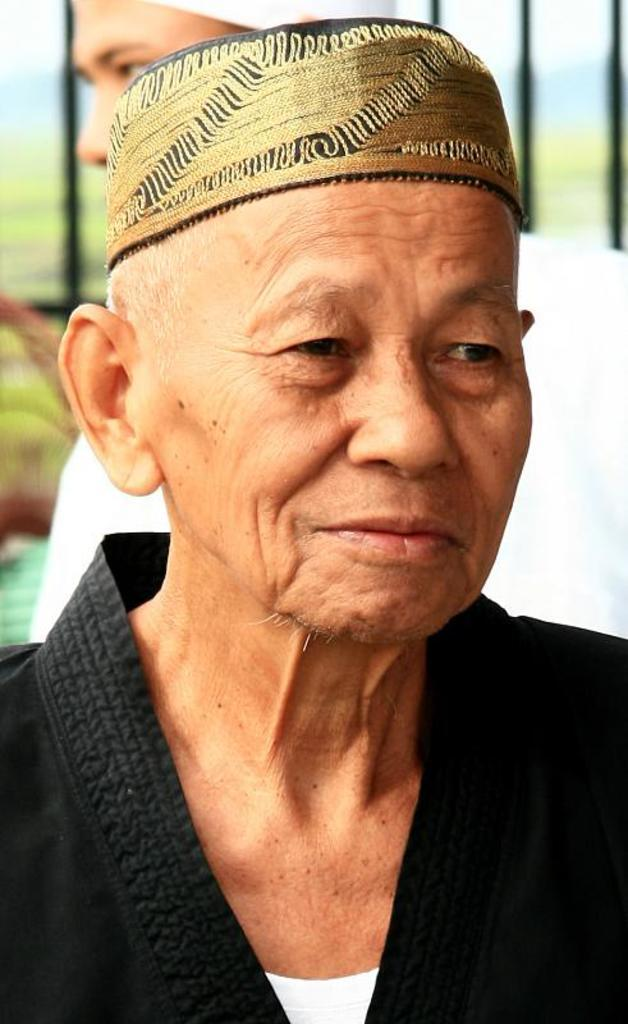What is the man in the foreground of the image wearing? The man in the foreground is wearing a black dress. Can you describe the man in the background of the image? The man in the background is wearing a cap. How many people are visible in the image? There are two people visible in the image. How many apples are on the bike in the image? There is no bike or apples present in the image. 